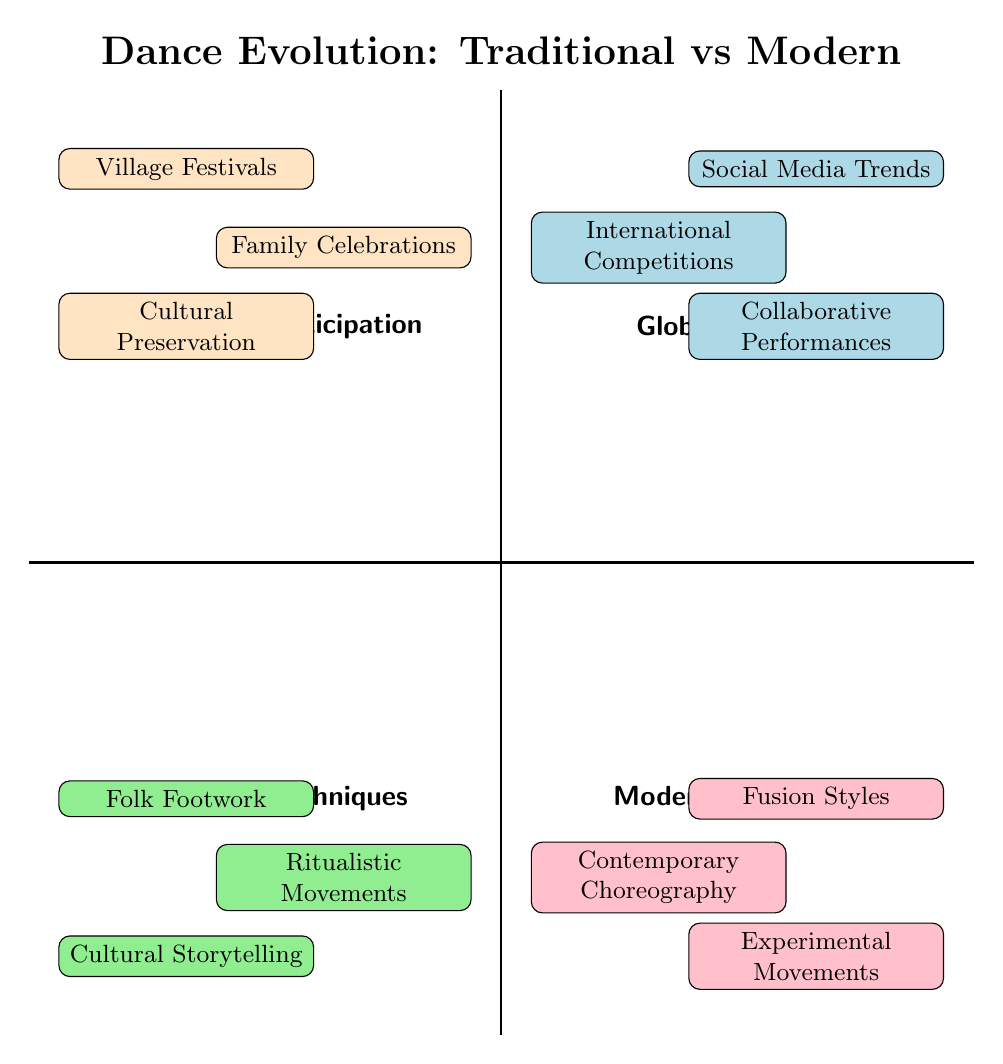What are the three elements in the Traditional Techniques quadrant? The Traditional Techniques quadrant is at the bottom left of the diagram, and it contains three elements: Folk Footwork, Ritualistic Movements, and Cultural Storytelling.
Answer: Folk Footwork, Ritualistic Movements, Cultural Storytelling How many elements are in the Community Participation quadrant? The Community Participation quadrant is located in the top left of the diagram. It has three elements: Village Festivals, Family Celebrations, and Cultural Preservation. Therefore, it contains a total of three elements.
Answer: 3 Which quadrant contains International Competitions? The International Competitions element is located in the top right quadrant of the diagram, which is labeled Global Influence.
Answer: Global Influence What is the relationship between Cultural Storytelling and Social Media Trends in the diagram? Cultural Storytelling is located in the bottom left quadrant (Traditional Techniques), while Social Media Trends is in the top right quadrant (Global Influence). They reflect contrasting aspects of dance evolution, combining traditional techniques with the influence of modern global trends.
Answer: Contrasting aspects Which quadrant has the element Contemporary Choreography? Contemporary Choreography can be found in the bottom right quadrant of the diagram, known as Modern Adaptation.
Answer: Modern Adaptation How many quadrants are related to community-based dance practices? There are two quadrants related to community-based dance practices: Community Participation (top left) emphasizes community activities and cultural preservation, while Traditional Techniques (bottom left) highlights traditional movements with a communal origin. Therefore, there are two quadrants related to this theme.
Answer: 2 Identify the element that completes the pairing with Ritualistic Movements in terms of contrasting approach. Ritualistic Movements in the Traditional Techniques quadrant pairs with Experimental Movements in the Modern Adaptation quadrant. This pairing symbolizes the difference between established ceremonial practices and innovative dance forms.
Answer: Experimental Movements Which element reflects a modern adaptation of dance while promoting cross-cultural interactions? Fusion Styles, located in the bottom right quadrant (Modern Adaptation), represents a modern adaptation of dance that encourages blending different cultural elements, fostering cross-cultural interactions.
Answer: Fusion Styles What distinguishes the Cultural Preservation element from the Social Media Trends element? Cultural Preservation, found in the Community Participation quadrant, focuses on maintaining traditional dance forms and practices, whereas Social Media Trends, located in the Global Influence quadrant, reflects the dynamic nature of modern dance influenced by technology and global communication.
Answer: Focus on tradition vs. dynamic modernity 